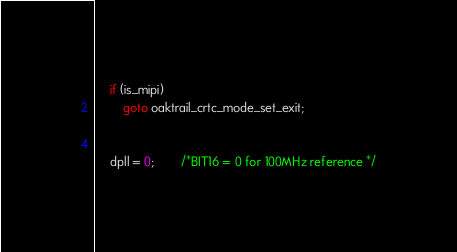Convert code to text. <code><loc_0><loc_0><loc_500><loc_500><_C_>
	if (is_mipi)
		goto oaktrail_crtc_mode_set_exit;


	dpll = 0;		/*BIT16 = 0 for 100MHz reference */
</code> 